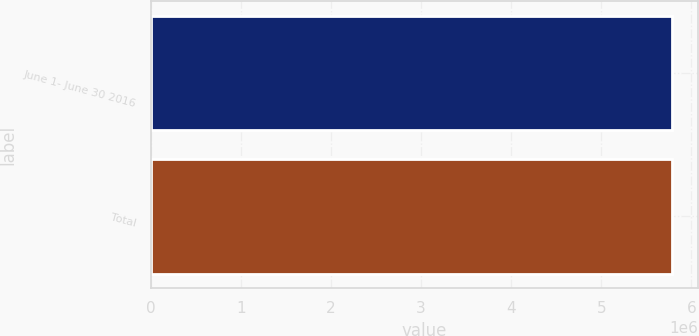Convert chart to OTSL. <chart><loc_0><loc_0><loc_500><loc_500><bar_chart><fcel>June 1- June 30 2016<fcel>Total<nl><fcel>5.7821e+06<fcel>5.7821e+06<nl></chart> 